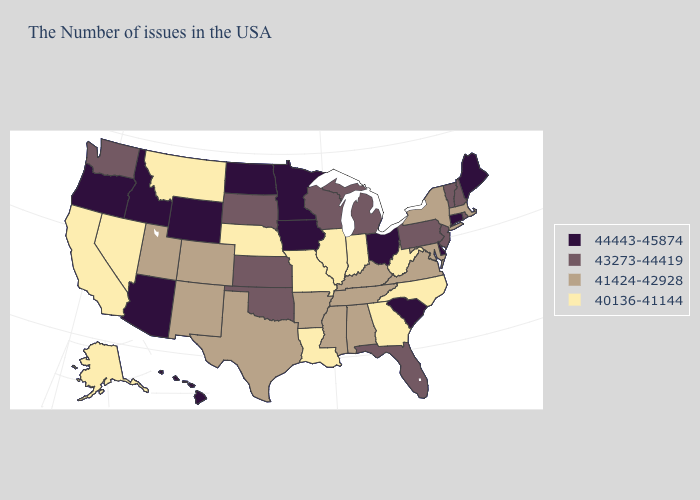Name the states that have a value in the range 44443-45874?
Concise answer only. Maine, Connecticut, Delaware, South Carolina, Ohio, Minnesota, Iowa, North Dakota, Wyoming, Arizona, Idaho, Oregon, Hawaii. Name the states that have a value in the range 40136-41144?
Answer briefly. North Carolina, West Virginia, Georgia, Indiana, Illinois, Louisiana, Missouri, Nebraska, Montana, Nevada, California, Alaska. Is the legend a continuous bar?
Short answer required. No. Among the states that border Oklahoma , does Missouri have the highest value?
Short answer required. No. Which states have the lowest value in the USA?
Quick response, please. North Carolina, West Virginia, Georgia, Indiana, Illinois, Louisiana, Missouri, Nebraska, Montana, Nevada, California, Alaska. What is the highest value in the USA?
Concise answer only. 44443-45874. Among the states that border Washington , which have the highest value?
Write a very short answer. Idaho, Oregon. What is the lowest value in the USA?
Short answer required. 40136-41144. What is the highest value in the USA?
Be succinct. 44443-45874. How many symbols are there in the legend?
Keep it brief. 4. Name the states that have a value in the range 41424-42928?
Concise answer only. Massachusetts, New York, Maryland, Virginia, Kentucky, Alabama, Tennessee, Mississippi, Arkansas, Texas, Colorado, New Mexico, Utah. What is the value of Connecticut?
Be succinct. 44443-45874. Among the states that border Nevada , which have the lowest value?
Quick response, please. California. Name the states that have a value in the range 43273-44419?
Write a very short answer. Rhode Island, New Hampshire, Vermont, New Jersey, Pennsylvania, Florida, Michigan, Wisconsin, Kansas, Oklahoma, South Dakota, Washington. Does New York have the same value as Georgia?
Write a very short answer. No. 